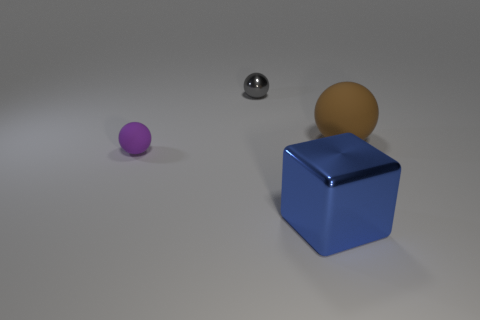Add 3 big green balls. How many objects exist? 7 Subtract all cubes. How many objects are left? 3 Subtract 0 cyan blocks. How many objects are left? 4 Subtract all big cubes. Subtract all small red rubber cylinders. How many objects are left? 3 Add 2 small rubber balls. How many small rubber balls are left? 3 Add 1 tiny metal objects. How many tiny metal objects exist? 2 